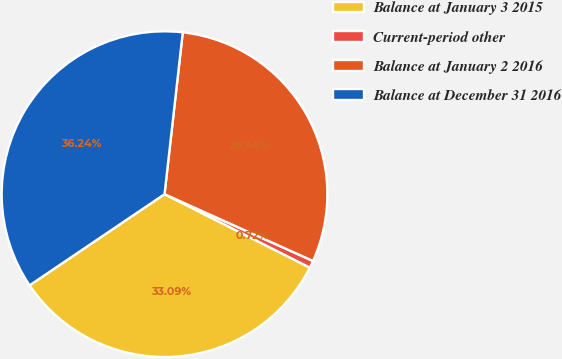Convert chart. <chart><loc_0><loc_0><loc_500><loc_500><pie_chart><fcel>Balance at January 3 2015<fcel>Current-period other<fcel>Balance at January 2 2016<fcel>Balance at December 31 2016<nl><fcel>33.09%<fcel>0.72%<fcel>29.94%<fcel>36.24%<nl></chart> 